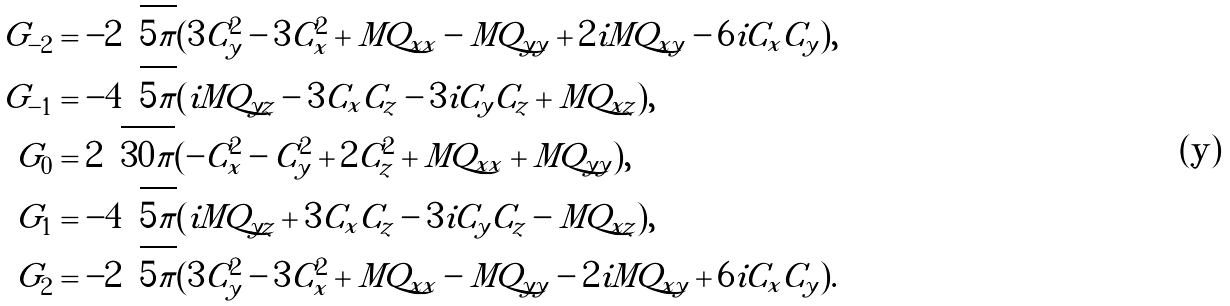Convert formula to latex. <formula><loc_0><loc_0><loc_500><loc_500>G _ { - 2 } & = - 2 \sqrt { 5 \pi } ( 3 C _ { y } ^ { 2 } - 3 C _ { x } ^ { 2 } + M Q _ { x x } - M Q _ { y y } + 2 i M Q _ { x y } - 6 i C _ { x } C _ { y } ) , \\ G _ { - 1 } & = - 4 \sqrt { 5 \pi } ( i M Q _ { y z } - 3 C _ { x } C _ { z } - 3 i C _ { y } C _ { z } + M Q _ { x z } ) , \\ G _ { 0 } & = 2 \sqrt { 3 0 \pi } ( - C _ { x } ^ { 2 } - C _ { y } ^ { 2 } + 2 C _ { z } ^ { 2 } + M Q _ { x x } + M Q _ { y y } ) , \\ G _ { 1 } & = - 4 \sqrt { 5 \pi } ( i M Q _ { y z } + 3 C _ { x } C _ { z } - 3 i C _ { y } C _ { z } - M Q _ { x z } ) , \\ G _ { 2 } & = - 2 \sqrt { 5 \pi } ( 3 C _ { y } ^ { 2 } - 3 C _ { x } ^ { 2 } + M Q _ { x x } - M Q _ { y y } - 2 i M Q _ { x y } + 6 i C _ { x } C _ { y } ) .</formula> 